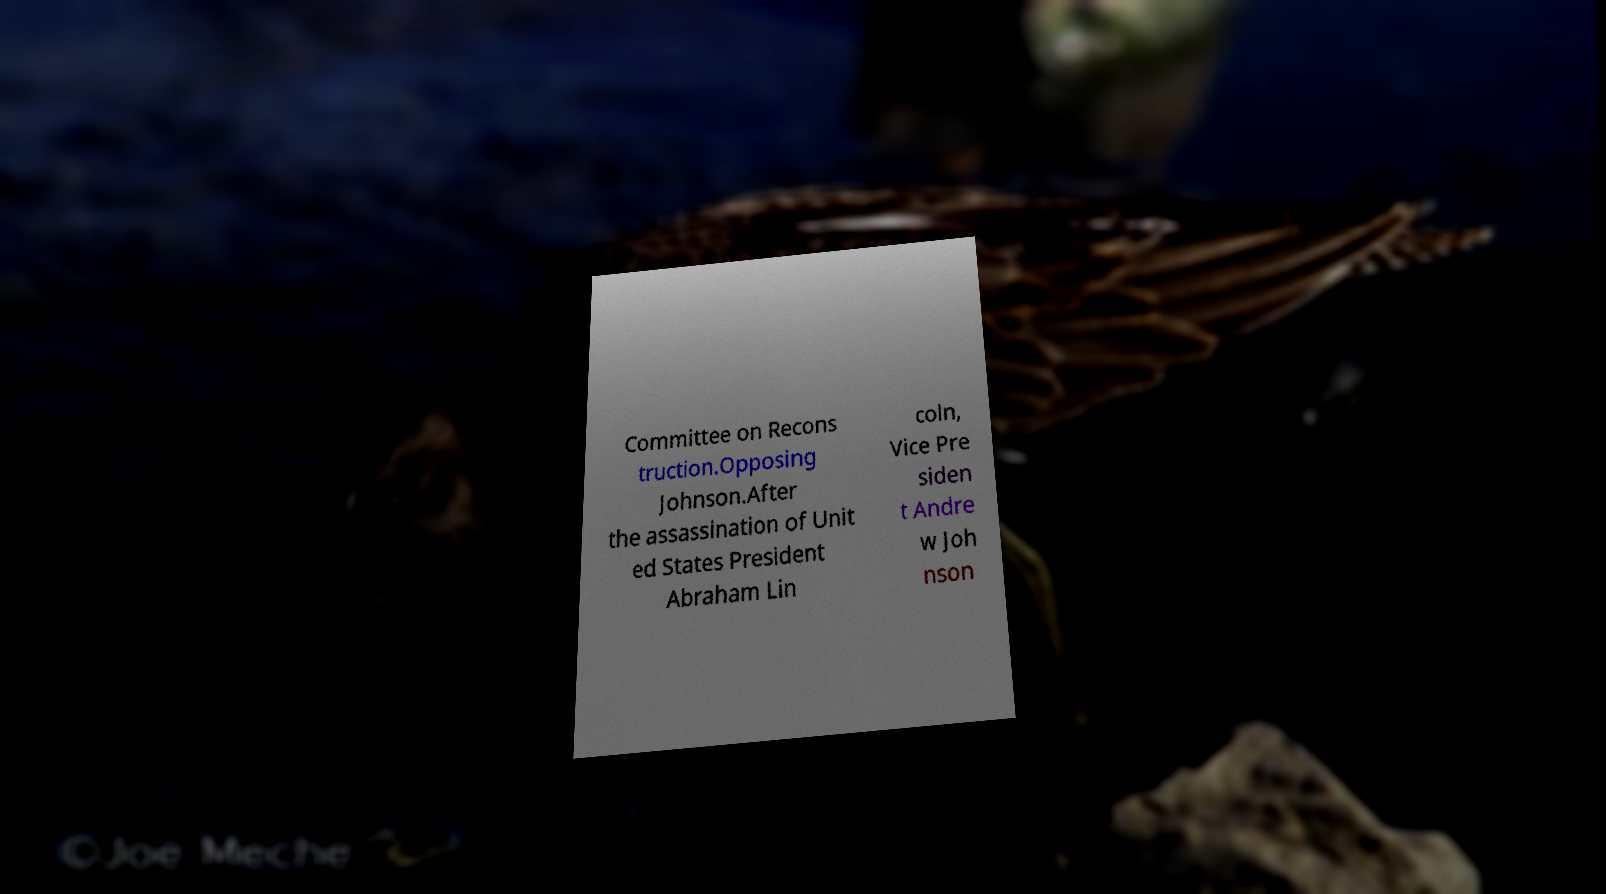There's text embedded in this image that I need extracted. Can you transcribe it verbatim? Committee on Recons truction.Opposing Johnson.After the assassination of Unit ed States President Abraham Lin coln, Vice Pre siden t Andre w Joh nson 